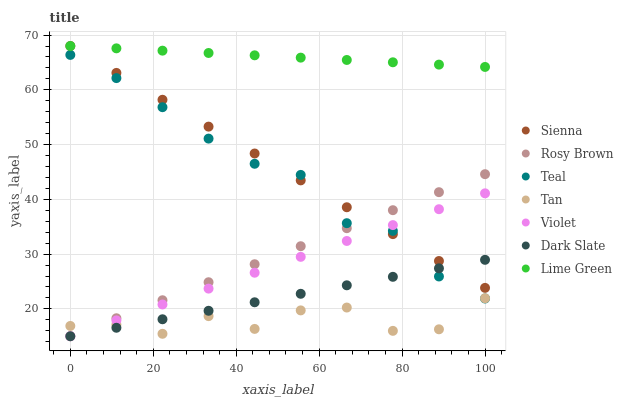Does Tan have the minimum area under the curve?
Answer yes or no. Yes. Does Lime Green have the maximum area under the curve?
Answer yes or no. Yes. Does Sienna have the minimum area under the curve?
Answer yes or no. No. Does Sienna have the maximum area under the curve?
Answer yes or no. No. Is Dark Slate the smoothest?
Answer yes or no. Yes. Is Tan the roughest?
Answer yes or no. Yes. Is Sienna the smoothest?
Answer yes or no. No. Is Sienna the roughest?
Answer yes or no. No. Does Rosy Brown have the lowest value?
Answer yes or no. Yes. Does Sienna have the lowest value?
Answer yes or no. No. Does Lime Green have the highest value?
Answer yes or no. Yes. Does Dark Slate have the highest value?
Answer yes or no. No. Is Dark Slate less than Lime Green?
Answer yes or no. Yes. Is Lime Green greater than Violet?
Answer yes or no. Yes. Does Tan intersect Dark Slate?
Answer yes or no. Yes. Is Tan less than Dark Slate?
Answer yes or no. No. Is Tan greater than Dark Slate?
Answer yes or no. No. Does Dark Slate intersect Lime Green?
Answer yes or no. No. 